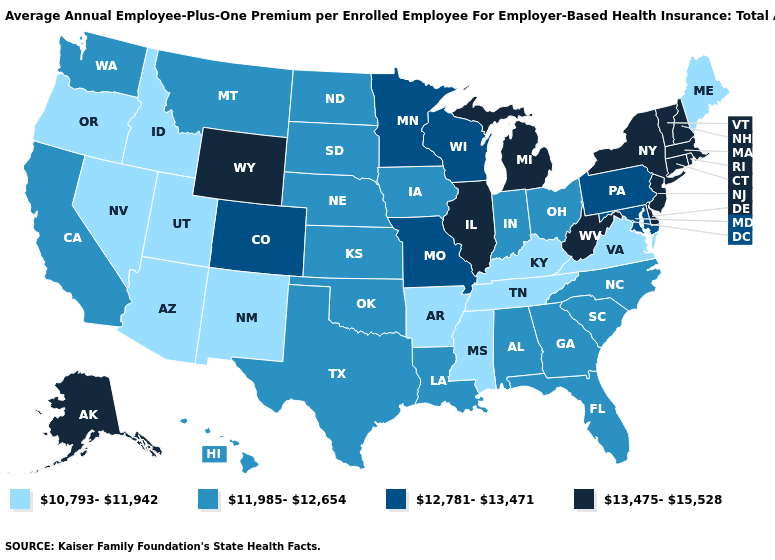Among the states that border Wisconsin , does Iowa have the lowest value?
Write a very short answer. Yes. What is the value of Mississippi?
Answer briefly. 10,793-11,942. Does Arkansas have the same value as Illinois?
Give a very brief answer. No. How many symbols are there in the legend?
Write a very short answer. 4. Name the states that have a value in the range 11,985-12,654?
Answer briefly. Alabama, California, Florida, Georgia, Hawaii, Indiana, Iowa, Kansas, Louisiana, Montana, Nebraska, North Carolina, North Dakota, Ohio, Oklahoma, South Carolina, South Dakota, Texas, Washington. Does Illinois have the highest value in the MidWest?
Concise answer only. Yes. What is the value of Montana?
Concise answer only. 11,985-12,654. Name the states that have a value in the range 13,475-15,528?
Quick response, please. Alaska, Connecticut, Delaware, Illinois, Massachusetts, Michigan, New Hampshire, New Jersey, New York, Rhode Island, Vermont, West Virginia, Wyoming. Does Connecticut have the highest value in the USA?
Write a very short answer. Yes. Name the states that have a value in the range 10,793-11,942?
Short answer required. Arizona, Arkansas, Idaho, Kentucky, Maine, Mississippi, Nevada, New Mexico, Oregon, Tennessee, Utah, Virginia. What is the value of Oklahoma?
Keep it brief. 11,985-12,654. What is the value of New Hampshire?
Give a very brief answer. 13,475-15,528. Among the states that border Oklahoma , which have the lowest value?
Write a very short answer. Arkansas, New Mexico. Does Arizona have the lowest value in the USA?
Quick response, please. Yes. 